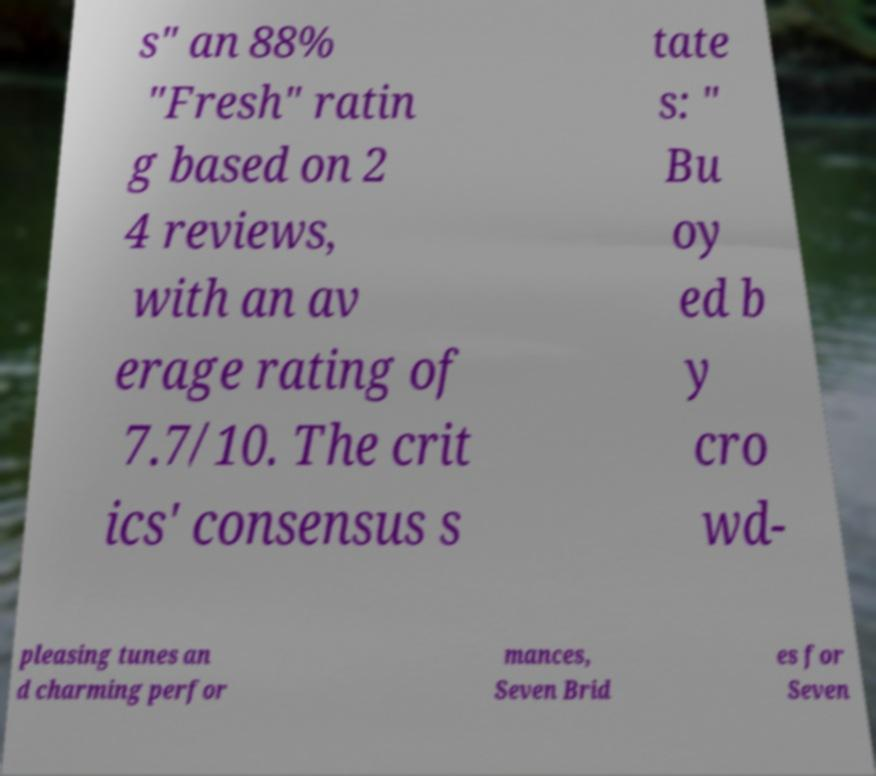What messages or text are displayed in this image? I need them in a readable, typed format. s" an 88% "Fresh" ratin g based on 2 4 reviews, with an av erage rating of 7.7/10. The crit ics' consensus s tate s: " Bu oy ed b y cro wd- pleasing tunes an d charming perfor mances, Seven Brid es for Seven 